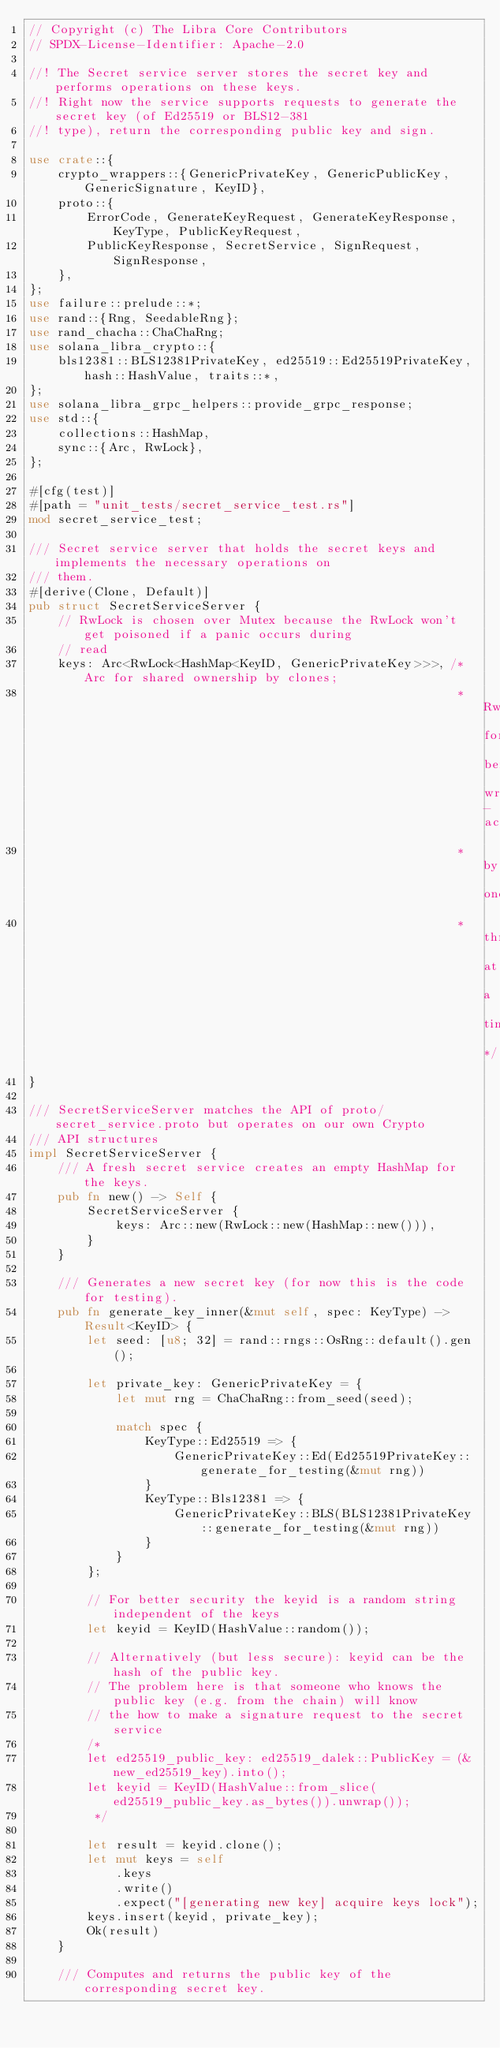Convert code to text. <code><loc_0><loc_0><loc_500><loc_500><_Rust_>// Copyright (c) The Libra Core Contributors
// SPDX-License-Identifier: Apache-2.0

//! The Secret service server stores the secret key and performs operations on these keys.
//! Right now the service supports requests to generate the secret key (of Ed25519 or BLS12-381
//! type), return the corresponding public key and sign.

use crate::{
    crypto_wrappers::{GenericPrivateKey, GenericPublicKey, GenericSignature, KeyID},
    proto::{
        ErrorCode, GenerateKeyRequest, GenerateKeyResponse, KeyType, PublicKeyRequest,
        PublicKeyResponse, SecretService, SignRequest, SignResponse,
    },
};
use failure::prelude::*;
use rand::{Rng, SeedableRng};
use rand_chacha::ChaChaRng;
use solana_libra_crypto::{
    bls12381::BLS12381PrivateKey, ed25519::Ed25519PrivateKey, hash::HashValue, traits::*,
};
use solana_libra_grpc_helpers::provide_grpc_response;
use std::{
    collections::HashMap,
    sync::{Arc, RwLock},
};

#[cfg(test)]
#[path = "unit_tests/secret_service_test.rs"]
mod secret_service_test;

/// Secret service server that holds the secret keys and implements the necessary operations on
/// them.
#[derive(Clone, Default)]
pub struct SecretServiceServer {
    // RwLock is chosen over Mutex because the RwLock won't get poisoned if a panic occurs during
    // read
    keys: Arc<RwLock<HashMap<KeyID, GenericPrivateKey>>>, /* Arc for shared ownership by clones;
                                                           * RwLock for being write-accessible
                                                           * by one
                                                           * thread at a time */
}

/// SecretServiceServer matches the API of proto/secret_service.proto but operates on our own Crypto
/// API structures
impl SecretServiceServer {
    /// A fresh secret service creates an empty HashMap for the keys.
    pub fn new() -> Self {
        SecretServiceServer {
            keys: Arc::new(RwLock::new(HashMap::new())),
        }
    }

    /// Generates a new secret key (for now this is the code for testing).
    pub fn generate_key_inner(&mut self, spec: KeyType) -> Result<KeyID> {
        let seed: [u8; 32] = rand::rngs::OsRng::default().gen();

        let private_key: GenericPrivateKey = {
            let mut rng = ChaChaRng::from_seed(seed);

            match spec {
                KeyType::Ed25519 => {
                    GenericPrivateKey::Ed(Ed25519PrivateKey::generate_for_testing(&mut rng))
                }
                KeyType::Bls12381 => {
                    GenericPrivateKey::BLS(BLS12381PrivateKey::generate_for_testing(&mut rng))
                }
            }
        };

        // For better security the keyid is a random string independent of the keys
        let keyid = KeyID(HashValue::random());

        // Alternatively (but less secure): keyid can be the hash of the public key.
        // The problem here is that someone who knows the public key (e.g. from the chain) will know
        // the how to make a signature request to the secret service
        /*
        let ed25519_public_key: ed25519_dalek::PublicKey = (&new_ed25519_key).into();
        let keyid = KeyID(HashValue::from_slice(ed25519_public_key.as_bytes()).unwrap());
         */

        let result = keyid.clone();
        let mut keys = self
            .keys
            .write()
            .expect("[generating new key] acquire keys lock");
        keys.insert(keyid, private_key);
        Ok(result)
    }

    /// Computes and returns the public key of the corresponding secret key.</code> 